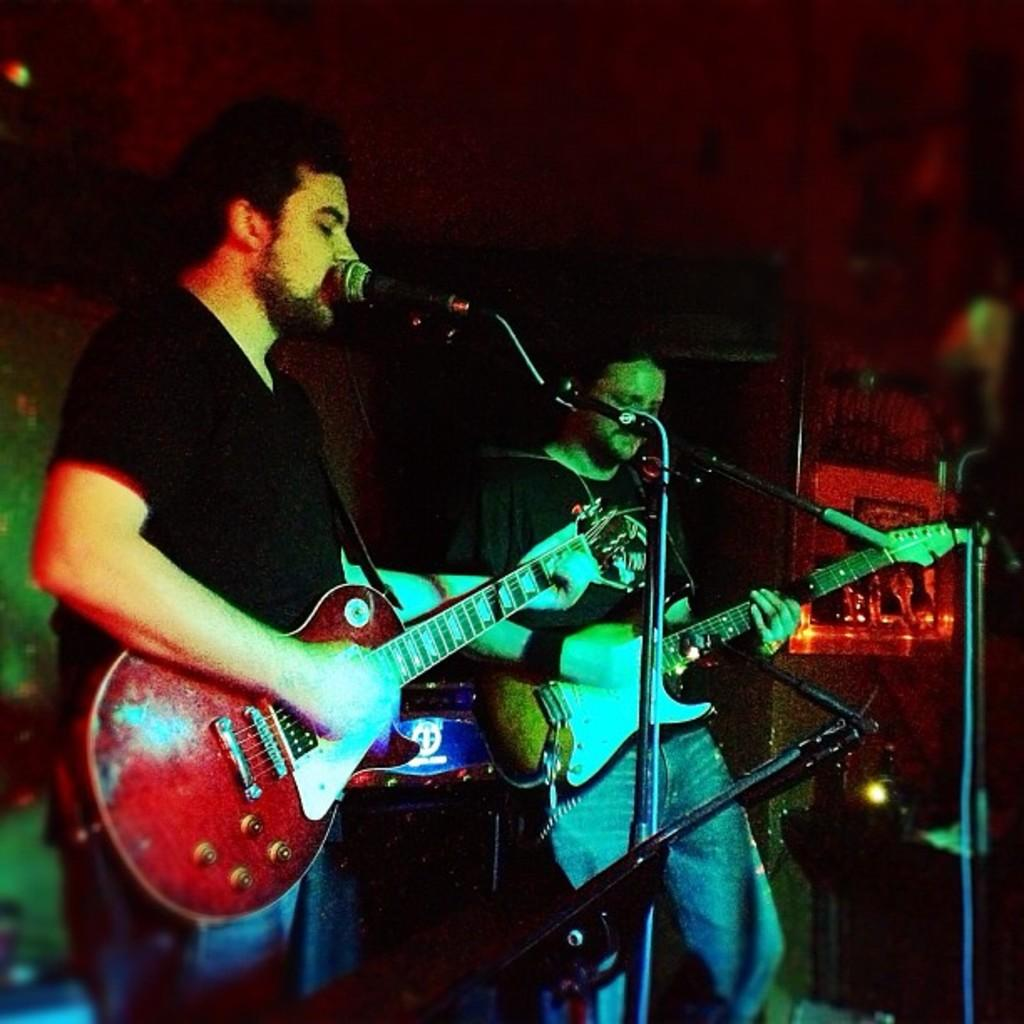How many people are in the image? There are two people in the image. What are the two people doing? The two people are standing and playing guitars. What objects are present at the front of the image? There are microphones at the front of the image. How many bears can be seen playing guitars with the two people in the image? There are no bears present in the image; it features two people playing guitars. What type of hair is visible on the people in the image? The provided facts do not mention any details about the people's hair, so we cannot determine the type of hair visible in the image. 